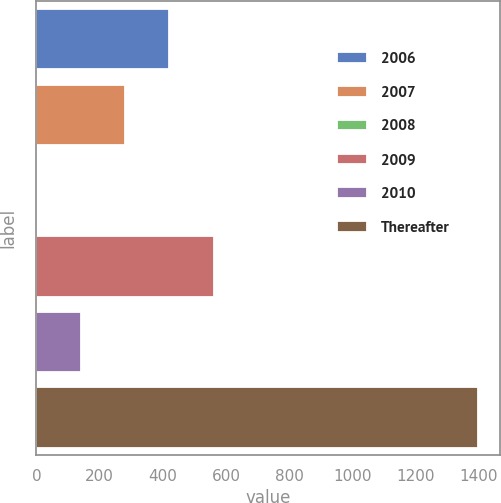Convert chart to OTSL. <chart><loc_0><loc_0><loc_500><loc_500><bar_chart><fcel>2006<fcel>2007<fcel>2008<fcel>2009<fcel>2010<fcel>Thereafter<nl><fcel>420.85<fcel>281.3<fcel>2.2<fcel>560.4<fcel>141.75<fcel>1397.7<nl></chart> 